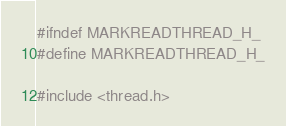<code> <loc_0><loc_0><loc_500><loc_500><_C_>#ifndef MARKREADTHREAD_H_
#define MARKREADTHREAD_H_

#include <thread.h></code> 